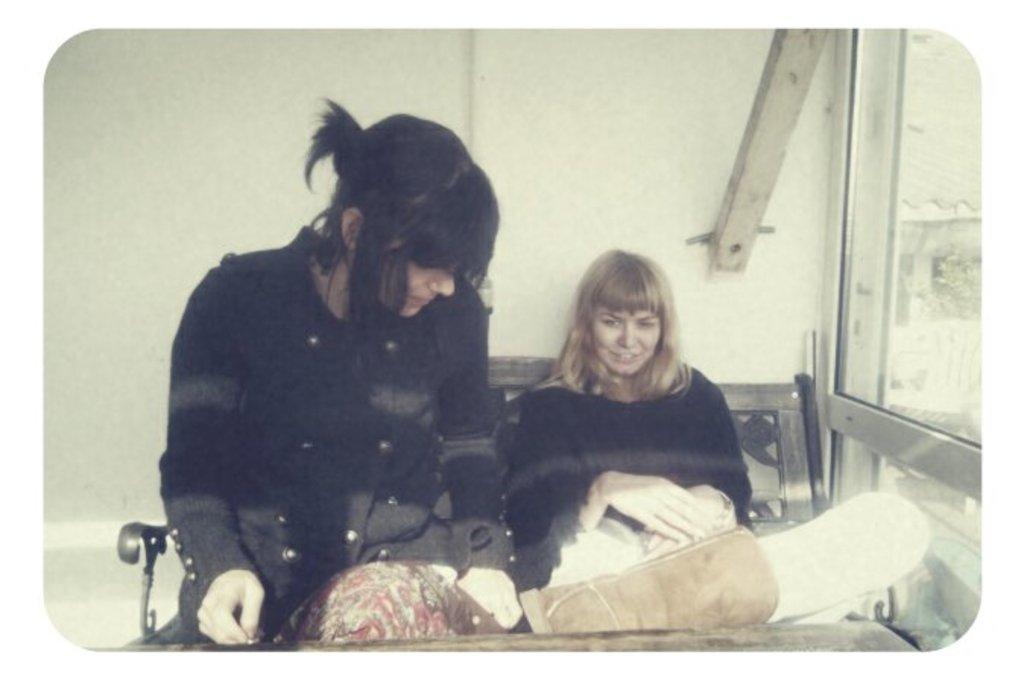Could you give a brief overview of what you see in this image? In the center of the image we can see two ladies sitting on the bench, before them there is a table. On the right there is a door. In the background we can see a wall. 